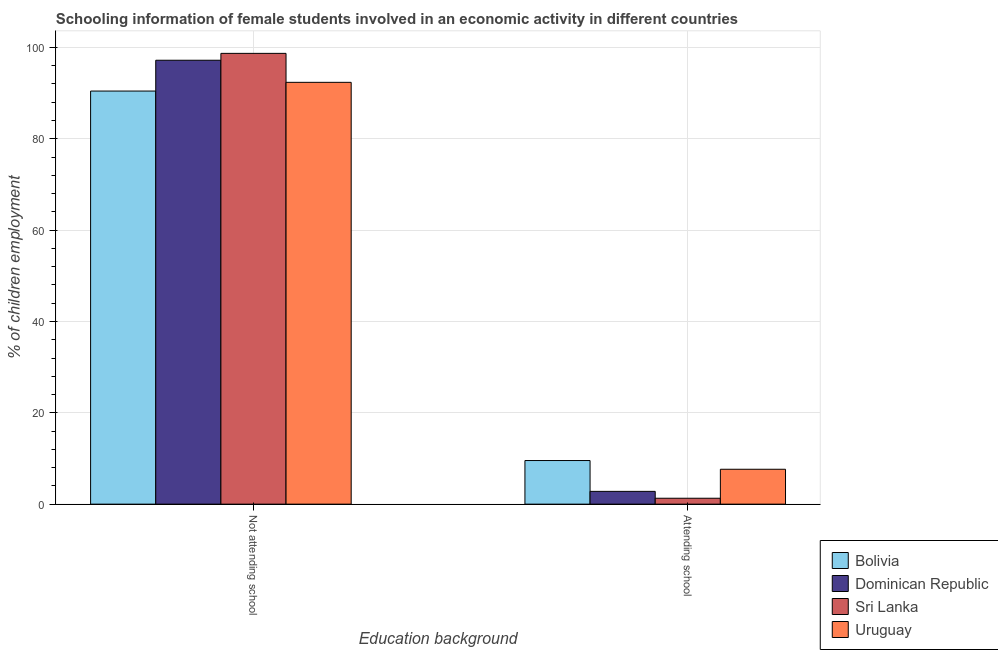Are the number of bars per tick equal to the number of legend labels?
Offer a terse response. Yes. What is the label of the 1st group of bars from the left?
Offer a very short reply. Not attending school. What is the percentage of employed females who are not attending school in Uruguay?
Offer a terse response. 92.36. Across all countries, what is the maximum percentage of employed females who are not attending school?
Provide a short and direct response. 98.71. Across all countries, what is the minimum percentage of employed females who are attending school?
Make the answer very short. 1.29. In which country was the percentage of employed females who are attending school maximum?
Your response must be concise. Bolivia. In which country was the percentage of employed females who are attending school minimum?
Provide a short and direct response. Sri Lanka. What is the total percentage of employed females who are attending school in the graph?
Give a very brief answer. 21.28. What is the difference between the percentage of employed females who are attending school in Bolivia and that in Sri Lanka?
Your answer should be very brief. 8.25. What is the difference between the percentage of employed females who are not attending school in Uruguay and the percentage of employed females who are attending school in Sri Lanka?
Offer a terse response. 91.06. What is the average percentage of employed females who are not attending school per country?
Provide a short and direct response. 94.68. What is the difference between the percentage of employed females who are attending school and percentage of employed females who are not attending school in Sri Lanka?
Provide a short and direct response. -97.41. What is the ratio of the percentage of employed females who are not attending school in Dominican Republic to that in Bolivia?
Provide a succinct answer. 1.07. Is the percentage of employed females who are attending school in Uruguay less than that in Sri Lanka?
Your response must be concise. No. What does the 4th bar from the left in Attending school represents?
Your answer should be very brief. Uruguay. What does the 2nd bar from the right in Not attending school represents?
Offer a terse response. Sri Lanka. Are all the bars in the graph horizontal?
Provide a short and direct response. No. Does the graph contain grids?
Provide a succinct answer. Yes. Where does the legend appear in the graph?
Your response must be concise. Bottom right. How many legend labels are there?
Make the answer very short. 4. What is the title of the graph?
Provide a short and direct response. Schooling information of female students involved in an economic activity in different countries. Does "Netherlands" appear as one of the legend labels in the graph?
Your answer should be compact. No. What is the label or title of the X-axis?
Give a very brief answer. Education background. What is the label or title of the Y-axis?
Your response must be concise. % of children employment. What is the % of children employment in Bolivia in Not attending school?
Your answer should be compact. 90.45. What is the % of children employment of Dominican Republic in Not attending school?
Make the answer very short. 97.2. What is the % of children employment of Sri Lanka in Not attending school?
Your answer should be compact. 98.71. What is the % of children employment in Uruguay in Not attending school?
Your answer should be compact. 92.36. What is the % of children employment in Bolivia in Attending school?
Your answer should be compact. 9.55. What is the % of children employment in Sri Lanka in Attending school?
Provide a succinct answer. 1.29. What is the % of children employment in Uruguay in Attending school?
Keep it short and to the point. 7.64. Across all Education background, what is the maximum % of children employment in Bolivia?
Offer a very short reply. 90.45. Across all Education background, what is the maximum % of children employment of Dominican Republic?
Your answer should be very brief. 97.2. Across all Education background, what is the maximum % of children employment in Sri Lanka?
Your answer should be compact. 98.71. Across all Education background, what is the maximum % of children employment of Uruguay?
Your answer should be very brief. 92.36. Across all Education background, what is the minimum % of children employment in Bolivia?
Offer a very short reply. 9.55. Across all Education background, what is the minimum % of children employment of Sri Lanka?
Your answer should be very brief. 1.29. Across all Education background, what is the minimum % of children employment of Uruguay?
Ensure brevity in your answer.  7.64. What is the total % of children employment in Bolivia in the graph?
Keep it short and to the point. 100. What is the total % of children employment in Dominican Republic in the graph?
Your answer should be compact. 100. What is the difference between the % of children employment of Bolivia in Not attending school and that in Attending school?
Provide a short and direct response. 80.9. What is the difference between the % of children employment of Dominican Republic in Not attending school and that in Attending school?
Offer a terse response. 94.4. What is the difference between the % of children employment of Sri Lanka in Not attending school and that in Attending school?
Provide a short and direct response. 97.41. What is the difference between the % of children employment in Uruguay in Not attending school and that in Attending school?
Your answer should be very brief. 84.72. What is the difference between the % of children employment of Bolivia in Not attending school and the % of children employment of Dominican Republic in Attending school?
Your answer should be compact. 87.65. What is the difference between the % of children employment of Bolivia in Not attending school and the % of children employment of Sri Lanka in Attending school?
Offer a terse response. 89.16. What is the difference between the % of children employment of Bolivia in Not attending school and the % of children employment of Uruguay in Attending school?
Ensure brevity in your answer.  82.81. What is the difference between the % of children employment of Dominican Republic in Not attending school and the % of children employment of Sri Lanka in Attending school?
Offer a terse response. 95.91. What is the difference between the % of children employment of Dominican Republic in Not attending school and the % of children employment of Uruguay in Attending school?
Make the answer very short. 89.56. What is the difference between the % of children employment of Sri Lanka in Not attending school and the % of children employment of Uruguay in Attending school?
Provide a succinct answer. 91.06. What is the average % of children employment of Sri Lanka per Education background?
Your answer should be very brief. 50. What is the difference between the % of children employment in Bolivia and % of children employment in Dominican Republic in Not attending school?
Your answer should be compact. -6.75. What is the difference between the % of children employment in Bolivia and % of children employment in Sri Lanka in Not attending school?
Your answer should be compact. -8.25. What is the difference between the % of children employment of Bolivia and % of children employment of Uruguay in Not attending school?
Offer a very short reply. -1.91. What is the difference between the % of children employment in Dominican Republic and % of children employment in Sri Lanka in Not attending school?
Provide a short and direct response. -1.5. What is the difference between the % of children employment of Dominican Republic and % of children employment of Uruguay in Not attending school?
Your answer should be very brief. 4.84. What is the difference between the % of children employment in Sri Lanka and % of children employment in Uruguay in Not attending school?
Ensure brevity in your answer.  6.35. What is the difference between the % of children employment in Bolivia and % of children employment in Dominican Republic in Attending school?
Your answer should be very brief. 6.75. What is the difference between the % of children employment in Bolivia and % of children employment in Sri Lanka in Attending school?
Ensure brevity in your answer.  8.25. What is the difference between the % of children employment of Bolivia and % of children employment of Uruguay in Attending school?
Ensure brevity in your answer.  1.91. What is the difference between the % of children employment in Dominican Republic and % of children employment in Sri Lanka in Attending school?
Ensure brevity in your answer.  1.5. What is the difference between the % of children employment of Dominican Republic and % of children employment of Uruguay in Attending school?
Ensure brevity in your answer.  -4.84. What is the difference between the % of children employment in Sri Lanka and % of children employment in Uruguay in Attending school?
Keep it short and to the point. -6.35. What is the ratio of the % of children employment in Bolivia in Not attending school to that in Attending school?
Make the answer very short. 9.47. What is the ratio of the % of children employment of Dominican Republic in Not attending school to that in Attending school?
Keep it short and to the point. 34.71. What is the ratio of the % of children employment of Sri Lanka in Not attending school to that in Attending school?
Your answer should be very brief. 76.22. What is the ratio of the % of children employment of Uruguay in Not attending school to that in Attending school?
Provide a succinct answer. 12.09. What is the difference between the highest and the second highest % of children employment of Bolivia?
Ensure brevity in your answer.  80.9. What is the difference between the highest and the second highest % of children employment in Dominican Republic?
Offer a very short reply. 94.4. What is the difference between the highest and the second highest % of children employment of Sri Lanka?
Provide a succinct answer. 97.41. What is the difference between the highest and the second highest % of children employment of Uruguay?
Make the answer very short. 84.72. What is the difference between the highest and the lowest % of children employment of Bolivia?
Your response must be concise. 80.9. What is the difference between the highest and the lowest % of children employment of Dominican Republic?
Your response must be concise. 94.4. What is the difference between the highest and the lowest % of children employment of Sri Lanka?
Keep it short and to the point. 97.41. What is the difference between the highest and the lowest % of children employment in Uruguay?
Your response must be concise. 84.72. 